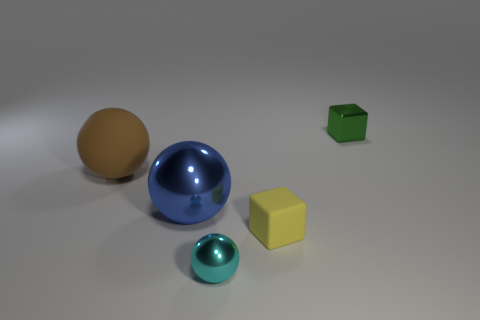Add 2 red objects. How many objects exist? 7 Subtract all blocks. How many objects are left? 3 Subtract all tiny matte spheres. Subtract all big brown matte spheres. How many objects are left? 4 Add 1 brown balls. How many brown balls are left? 2 Add 1 blue rubber balls. How many blue rubber balls exist? 1 Subtract 0 purple blocks. How many objects are left? 5 